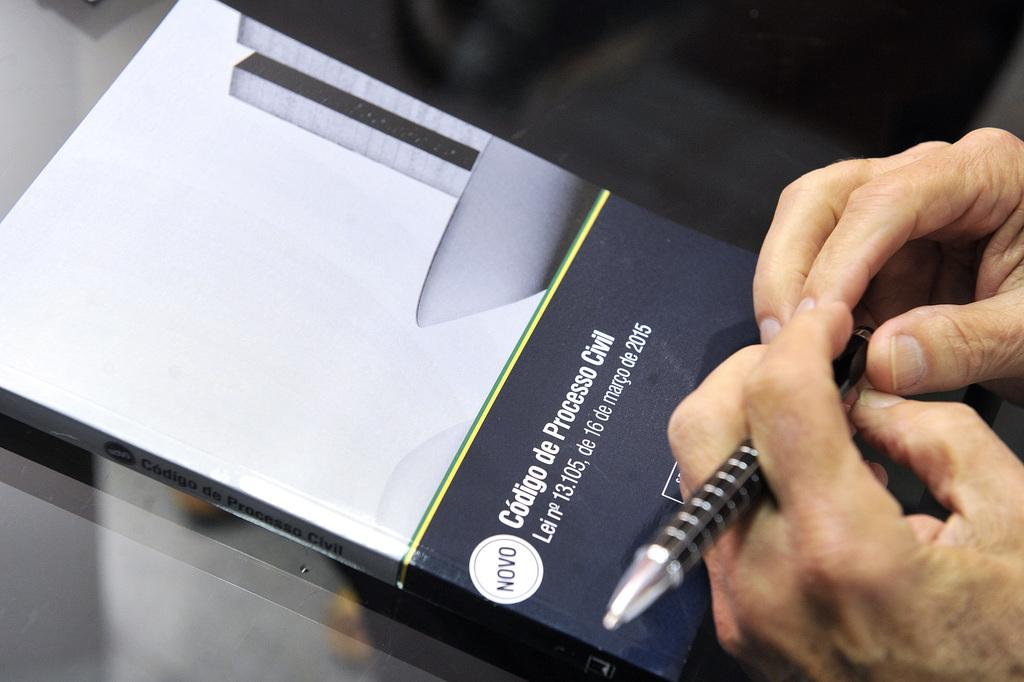What object related to reading and writing can be seen in the image? There is a book and a pen in the image. What part of a person is visible in the image? A person's hand is on the table in the image. What type of bee can be seen buzzing around the person's hand in the image? There is no bee present in the image; only a book, a pen, and a person's hand are visible. 